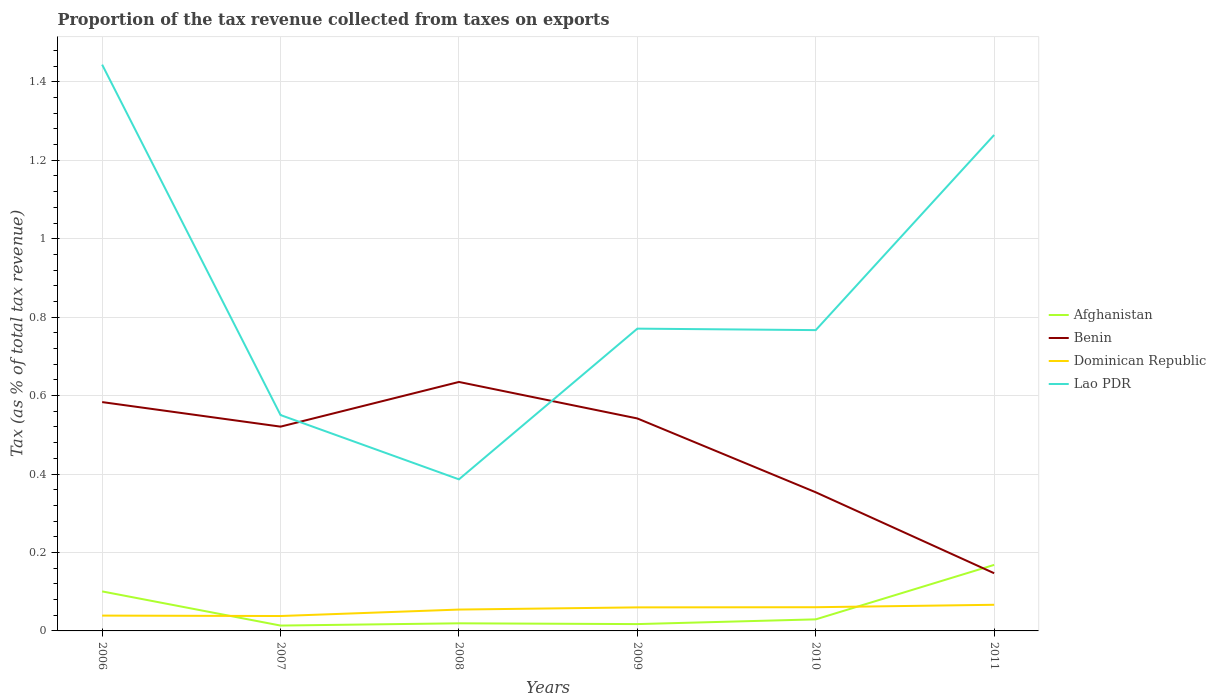How many different coloured lines are there?
Your answer should be compact. 4. Does the line corresponding to Lao PDR intersect with the line corresponding to Afghanistan?
Offer a very short reply. No. Is the number of lines equal to the number of legend labels?
Make the answer very short. Yes. Across all years, what is the maximum proportion of the tax revenue collected in Lao PDR?
Offer a very short reply. 0.39. What is the total proportion of the tax revenue collected in Afghanistan in the graph?
Offer a very short reply. -0.15. What is the difference between the highest and the second highest proportion of the tax revenue collected in Benin?
Keep it short and to the point. 0.49. What is the difference between the highest and the lowest proportion of the tax revenue collected in Lao PDR?
Provide a succinct answer. 2. Is the proportion of the tax revenue collected in Lao PDR strictly greater than the proportion of the tax revenue collected in Dominican Republic over the years?
Ensure brevity in your answer.  No. How many lines are there?
Ensure brevity in your answer.  4. Are the values on the major ticks of Y-axis written in scientific E-notation?
Provide a succinct answer. No. Does the graph contain any zero values?
Keep it short and to the point. No. Where does the legend appear in the graph?
Ensure brevity in your answer.  Center right. What is the title of the graph?
Make the answer very short. Proportion of the tax revenue collected from taxes on exports. Does "Israel" appear as one of the legend labels in the graph?
Your answer should be compact. No. What is the label or title of the Y-axis?
Offer a terse response. Tax (as % of total tax revenue). What is the Tax (as % of total tax revenue) of Afghanistan in 2006?
Make the answer very short. 0.1. What is the Tax (as % of total tax revenue) in Benin in 2006?
Give a very brief answer. 0.58. What is the Tax (as % of total tax revenue) of Dominican Republic in 2006?
Provide a succinct answer. 0.04. What is the Tax (as % of total tax revenue) in Lao PDR in 2006?
Offer a terse response. 1.44. What is the Tax (as % of total tax revenue) of Afghanistan in 2007?
Provide a succinct answer. 0.01. What is the Tax (as % of total tax revenue) of Benin in 2007?
Ensure brevity in your answer.  0.52. What is the Tax (as % of total tax revenue) of Dominican Republic in 2007?
Provide a short and direct response. 0.04. What is the Tax (as % of total tax revenue) of Lao PDR in 2007?
Your answer should be compact. 0.55. What is the Tax (as % of total tax revenue) in Afghanistan in 2008?
Give a very brief answer. 0.02. What is the Tax (as % of total tax revenue) in Benin in 2008?
Offer a very short reply. 0.63. What is the Tax (as % of total tax revenue) of Dominican Republic in 2008?
Keep it short and to the point. 0.05. What is the Tax (as % of total tax revenue) of Lao PDR in 2008?
Provide a short and direct response. 0.39. What is the Tax (as % of total tax revenue) in Afghanistan in 2009?
Make the answer very short. 0.02. What is the Tax (as % of total tax revenue) in Benin in 2009?
Ensure brevity in your answer.  0.54. What is the Tax (as % of total tax revenue) of Dominican Republic in 2009?
Provide a succinct answer. 0.06. What is the Tax (as % of total tax revenue) of Lao PDR in 2009?
Offer a very short reply. 0.77. What is the Tax (as % of total tax revenue) in Afghanistan in 2010?
Make the answer very short. 0.03. What is the Tax (as % of total tax revenue) in Benin in 2010?
Make the answer very short. 0.35. What is the Tax (as % of total tax revenue) of Dominican Republic in 2010?
Your answer should be very brief. 0.06. What is the Tax (as % of total tax revenue) in Lao PDR in 2010?
Provide a short and direct response. 0.77. What is the Tax (as % of total tax revenue) in Afghanistan in 2011?
Offer a very short reply. 0.17. What is the Tax (as % of total tax revenue) of Benin in 2011?
Ensure brevity in your answer.  0.15. What is the Tax (as % of total tax revenue) of Dominican Republic in 2011?
Offer a terse response. 0.07. What is the Tax (as % of total tax revenue) of Lao PDR in 2011?
Your answer should be compact. 1.26. Across all years, what is the maximum Tax (as % of total tax revenue) in Afghanistan?
Ensure brevity in your answer.  0.17. Across all years, what is the maximum Tax (as % of total tax revenue) of Benin?
Offer a very short reply. 0.63. Across all years, what is the maximum Tax (as % of total tax revenue) of Dominican Republic?
Keep it short and to the point. 0.07. Across all years, what is the maximum Tax (as % of total tax revenue) of Lao PDR?
Make the answer very short. 1.44. Across all years, what is the minimum Tax (as % of total tax revenue) of Afghanistan?
Provide a succinct answer. 0.01. Across all years, what is the minimum Tax (as % of total tax revenue) in Benin?
Make the answer very short. 0.15. Across all years, what is the minimum Tax (as % of total tax revenue) in Dominican Republic?
Offer a very short reply. 0.04. Across all years, what is the minimum Tax (as % of total tax revenue) in Lao PDR?
Provide a short and direct response. 0.39. What is the total Tax (as % of total tax revenue) in Afghanistan in the graph?
Offer a terse response. 0.35. What is the total Tax (as % of total tax revenue) of Benin in the graph?
Your answer should be compact. 2.78. What is the total Tax (as % of total tax revenue) in Dominican Republic in the graph?
Make the answer very short. 0.32. What is the total Tax (as % of total tax revenue) in Lao PDR in the graph?
Give a very brief answer. 5.18. What is the difference between the Tax (as % of total tax revenue) of Afghanistan in 2006 and that in 2007?
Your response must be concise. 0.09. What is the difference between the Tax (as % of total tax revenue) of Benin in 2006 and that in 2007?
Make the answer very short. 0.06. What is the difference between the Tax (as % of total tax revenue) of Dominican Republic in 2006 and that in 2007?
Give a very brief answer. 0. What is the difference between the Tax (as % of total tax revenue) in Lao PDR in 2006 and that in 2007?
Ensure brevity in your answer.  0.89. What is the difference between the Tax (as % of total tax revenue) of Afghanistan in 2006 and that in 2008?
Make the answer very short. 0.08. What is the difference between the Tax (as % of total tax revenue) of Benin in 2006 and that in 2008?
Offer a terse response. -0.05. What is the difference between the Tax (as % of total tax revenue) of Dominican Republic in 2006 and that in 2008?
Provide a succinct answer. -0.02. What is the difference between the Tax (as % of total tax revenue) in Lao PDR in 2006 and that in 2008?
Your answer should be very brief. 1.06. What is the difference between the Tax (as % of total tax revenue) of Afghanistan in 2006 and that in 2009?
Provide a succinct answer. 0.08. What is the difference between the Tax (as % of total tax revenue) in Benin in 2006 and that in 2009?
Your response must be concise. 0.04. What is the difference between the Tax (as % of total tax revenue) in Dominican Republic in 2006 and that in 2009?
Make the answer very short. -0.02. What is the difference between the Tax (as % of total tax revenue) of Lao PDR in 2006 and that in 2009?
Offer a terse response. 0.67. What is the difference between the Tax (as % of total tax revenue) of Afghanistan in 2006 and that in 2010?
Provide a short and direct response. 0.07. What is the difference between the Tax (as % of total tax revenue) in Benin in 2006 and that in 2010?
Your answer should be compact. 0.23. What is the difference between the Tax (as % of total tax revenue) of Dominican Republic in 2006 and that in 2010?
Keep it short and to the point. -0.02. What is the difference between the Tax (as % of total tax revenue) of Lao PDR in 2006 and that in 2010?
Your answer should be compact. 0.68. What is the difference between the Tax (as % of total tax revenue) in Afghanistan in 2006 and that in 2011?
Keep it short and to the point. -0.07. What is the difference between the Tax (as % of total tax revenue) in Benin in 2006 and that in 2011?
Offer a terse response. 0.44. What is the difference between the Tax (as % of total tax revenue) of Dominican Republic in 2006 and that in 2011?
Provide a short and direct response. -0.03. What is the difference between the Tax (as % of total tax revenue) of Lao PDR in 2006 and that in 2011?
Your answer should be compact. 0.18. What is the difference between the Tax (as % of total tax revenue) of Afghanistan in 2007 and that in 2008?
Provide a succinct answer. -0.01. What is the difference between the Tax (as % of total tax revenue) of Benin in 2007 and that in 2008?
Give a very brief answer. -0.11. What is the difference between the Tax (as % of total tax revenue) in Dominican Republic in 2007 and that in 2008?
Offer a very short reply. -0.02. What is the difference between the Tax (as % of total tax revenue) of Lao PDR in 2007 and that in 2008?
Your answer should be very brief. 0.16. What is the difference between the Tax (as % of total tax revenue) of Afghanistan in 2007 and that in 2009?
Offer a terse response. -0. What is the difference between the Tax (as % of total tax revenue) in Benin in 2007 and that in 2009?
Provide a succinct answer. -0.02. What is the difference between the Tax (as % of total tax revenue) of Dominican Republic in 2007 and that in 2009?
Provide a succinct answer. -0.02. What is the difference between the Tax (as % of total tax revenue) in Lao PDR in 2007 and that in 2009?
Your answer should be compact. -0.22. What is the difference between the Tax (as % of total tax revenue) of Afghanistan in 2007 and that in 2010?
Your answer should be compact. -0.02. What is the difference between the Tax (as % of total tax revenue) of Benin in 2007 and that in 2010?
Offer a very short reply. 0.17. What is the difference between the Tax (as % of total tax revenue) of Dominican Republic in 2007 and that in 2010?
Ensure brevity in your answer.  -0.02. What is the difference between the Tax (as % of total tax revenue) in Lao PDR in 2007 and that in 2010?
Offer a very short reply. -0.22. What is the difference between the Tax (as % of total tax revenue) of Afghanistan in 2007 and that in 2011?
Offer a terse response. -0.15. What is the difference between the Tax (as % of total tax revenue) in Benin in 2007 and that in 2011?
Offer a terse response. 0.37. What is the difference between the Tax (as % of total tax revenue) of Dominican Republic in 2007 and that in 2011?
Provide a short and direct response. -0.03. What is the difference between the Tax (as % of total tax revenue) of Lao PDR in 2007 and that in 2011?
Offer a very short reply. -0.71. What is the difference between the Tax (as % of total tax revenue) of Afghanistan in 2008 and that in 2009?
Keep it short and to the point. 0. What is the difference between the Tax (as % of total tax revenue) of Benin in 2008 and that in 2009?
Your response must be concise. 0.09. What is the difference between the Tax (as % of total tax revenue) of Dominican Republic in 2008 and that in 2009?
Keep it short and to the point. -0.01. What is the difference between the Tax (as % of total tax revenue) of Lao PDR in 2008 and that in 2009?
Keep it short and to the point. -0.38. What is the difference between the Tax (as % of total tax revenue) in Afghanistan in 2008 and that in 2010?
Ensure brevity in your answer.  -0.01. What is the difference between the Tax (as % of total tax revenue) in Benin in 2008 and that in 2010?
Provide a succinct answer. 0.28. What is the difference between the Tax (as % of total tax revenue) of Dominican Republic in 2008 and that in 2010?
Give a very brief answer. -0.01. What is the difference between the Tax (as % of total tax revenue) of Lao PDR in 2008 and that in 2010?
Provide a short and direct response. -0.38. What is the difference between the Tax (as % of total tax revenue) in Afghanistan in 2008 and that in 2011?
Keep it short and to the point. -0.15. What is the difference between the Tax (as % of total tax revenue) in Benin in 2008 and that in 2011?
Provide a short and direct response. 0.49. What is the difference between the Tax (as % of total tax revenue) of Dominican Republic in 2008 and that in 2011?
Provide a succinct answer. -0.01. What is the difference between the Tax (as % of total tax revenue) of Lao PDR in 2008 and that in 2011?
Ensure brevity in your answer.  -0.88. What is the difference between the Tax (as % of total tax revenue) in Afghanistan in 2009 and that in 2010?
Your answer should be very brief. -0.01. What is the difference between the Tax (as % of total tax revenue) in Benin in 2009 and that in 2010?
Provide a succinct answer. 0.19. What is the difference between the Tax (as % of total tax revenue) in Dominican Republic in 2009 and that in 2010?
Your response must be concise. -0. What is the difference between the Tax (as % of total tax revenue) of Lao PDR in 2009 and that in 2010?
Your answer should be very brief. 0. What is the difference between the Tax (as % of total tax revenue) in Afghanistan in 2009 and that in 2011?
Provide a succinct answer. -0.15. What is the difference between the Tax (as % of total tax revenue) in Benin in 2009 and that in 2011?
Make the answer very short. 0.39. What is the difference between the Tax (as % of total tax revenue) of Dominican Republic in 2009 and that in 2011?
Give a very brief answer. -0.01. What is the difference between the Tax (as % of total tax revenue) of Lao PDR in 2009 and that in 2011?
Ensure brevity in your answer.  -0.49. What is the difference between the Tax (as % of total tax revenue) of Afghanistan in 2010 and that in 2011?
Provide a short and direct response. -0.14. What is the difference between the Tax (as % of total tax revenue) of Benin in 2010 and that in 2011?
Make the answer very short. 0.21. What is the difference between the Tax (as % of total tax revenue) in Dominican Republic in 2010 and that in 2011?
Give a very brief answer. -0.01. What is the difference between the Tax (as % of total tax revenue) of Lao PDR in 2010 and that in 2011?
Make the answer very short. -0.5. What is the difference between the Tax (as % of total tax revenue) in Afghanistan in 2006 and the Tax (as % of total tax revenue) in Benin in 2007?
Ensure brevity in your answer.  -0.42. What is the difference between the Tax (as % of total tax revenue) in Afghanistan in 2006 and the Tax (as % of total tax revenue) in Dominican Republic in 2007?
Give a very brief answer. 0.06. What is the difference between the Tax (as % of total tax revenue) of Afghanistan in 2006 and the Tax (as % of total tax revenue) of Lao PDR in 2007?
Your answer should be compact. -0.45. What is the difference between the Tax (as % of total tax revenue) of Benin in 2006 and the Tax (as % of total tax revenue) of Dominican Republic in 2007?
Offer a very short reply. 0.55. What is the difference between the Tax (as % of total tax revenue) of Benin in 2006 and the Tax (as % of total tax revenue) of Lao PDR in 2007?
Your answer should be very brief. 0.03. What is the difference between the Tax (as % of total tax revenue) in Dominican Republic in 2006 and the Tax (as % of total tax revenue) in Lao PDR in 2007?
Your answer should be compact. -0.51. What is the difference between the Tax (as % of total tax revenue) of Afghanistan in 2006 and the Tax (as % of total tax revenue) of Benin in 2008?
Offer a terse response. -0.53. What is the difference between the Tax (as % of total tax revenue) in Afghanistan in 2006 and the Tax (as % of total tax revenue) in Dominican Republic in 2008?
Keep it short and to the point. 0.05. What is the difference between the Tax (as % of total tax revenue) in Afghanistan in 2006 and the Tax (as % of total tax revenue) in Lao PDR in 2008?
Make the answer very short. -0.29. What is the difference between the Tax (as % of total tax revenue) in Benin in 2006 and the Tax (as % of total tax revenue) in Dominican Republic in 2008?
Your response must be concise. 0.53. What is the difference between the Tax (as % of total tax revenue) of Benin in 2006 and the Tax (as % of total tax revenue) of Lao PDR in 2008?
Offer a terse response. 0.2. What is the difference between the Tax (as % of total tax revenue) of Dominican Republic in 2006 and the Tax (as % of total tax revenue) of Lao PDR in 2008?
Make the answer very short. -0.35. What is the difference between the Tax (as % of total tax revenue) in Afghanistan in 2006 and the Tax (as % of total tax revenue) in Benin in 2009?
Offer a very short reply. -0.44. What is the difference between the Tax (as % of total tax revenue) in Afghanistan in 2006 and the Tax (as % of total tax revenue) in Dominican Republic in 2009?
Ensure brevity in your answer.  0.04. What is the difference between the Tax (as % of total tax revenue) of Afghanistan in 2006 and the Tax (as % of total tax revenue) of Lao PDR in 2009?
Your answer should be very brief. -0.67. What is the difference between the Tax (as % of total tax revenue) of Benin in 2006 and the Tax (as % of total tax revenue) of Dominican Republic in 2009?
Ensure brevity in your answer.  0.52. What is the difference between the Tax (as % of total tax revenue) in Benin in 2006 and the Tax (as % of total tax revenue) in Lao PDR in 2009?
Provide a succinct answer. -0.19. What is the difference between the Tax (as % of total tax revenue) of Dominican Republic in 2006 and the Tax (as % of total tax revenue) of Lao PDR in 2009?
Offer a very short reply. -0.73. What is the difference between the Tax (as % of total tax revenue) in Afghanistan in 2006 and the Tax (as % of total tax revenue) in Benin in 2010?
Your answer should be very brief. -0.25. What is the difference between the Tax (as % of total tax revenue) of Afghanistan in 2006 and the Tax (as % of total tax revenue) of Dominican Republic in 2010?
Your response must be concise. 0.04. What is the difference between the Tax (as % of total tax revenue) in Afghanistan in 2006 and the Tax (as % of total tax revenue) in Lao PDR in 2010?
Your response must be concise. -0.67. What is the difference between the Tax (as % of total tax revenue) in Benin in 2006 and the Tax (as % of total tax revenue) in Dominican Republic in 2010?
Make the answer very short. 0.52. What is the difference between the Tax (as % of total tax revenue) of Benin in 2006 and the Tax (as % of total tax revenue) of Lao PDR in 2010?
Your response must be concise. -0.18. What is the difference between the Tax (as % of total tax revenue) of Dominican Republic in 2006 and the Tax (as % of total tax revenue) of Lao PDR in 2010?
Your answer should be compact. -0.73. What is the difference between the Tax (as % of total tax revenue) in Afghanistan in 2006 and the Tax (as % of total tax revenue) in Benin in 2011?
Provide a succinct answer. -0.05. What is the difference between the Tax (as % of total tax revenue) of Afghanistan in 2006 and the Tax (as % of total tax revenue) of Dominican Republic in 2011?
Provide a short and direct response. 0.03. What is the difference between the Tax (as % of total tax revenue) in Afghanistan in 2006 and the Tax (as % of total tax revenue) in Lao PDR in 2011?
Ensure brevity in your answer.  -1.16. What is the difference between the Tax (as % of total tax revenue) in Benin in 2006 and the Tax (as % of total tax revenue) in Dominican Republic in 2011?
Your answer should be very brief. 0.52. What is the difference between the Tax (as % of total tax revenue) of Benin in 2006 and the Tax (as % of total tax revenue) of Lao PDR in 2011?
Provide a short and direct response. -0.68. What is the difference between the Tax (as % of total tax revenue) of Dominican Republic in 2006 and the Tax (as % of total tax revenue) of Lao PDR in 2011?
Make the answer very short. -1.23. What is the difference between the Tax (as % of total tax revenue) in Afghanistan in 2007 and the Tax (as % of total tax revenue) in Benin in 2008?
Offer a terse response. -0.62. What is the difference between the Tax (as % of total tax revenue) of Afghanistan in 2007 and the Tax (as % of total tax revenue) of Dominican Republic in 2008?
Offer a terse response. -0.04. What is the difference between the Tax (as % of total tax revenue) of Afghanistan in 2007 and the Tax (as % of total tax revenue) of Lao PDR in 2008?
Ensure brevity in your answer.  -0.37. What is the difference between the Tax (as % of total tax revenue) in Benin in 2007 and the Tax (as % of total tax revenue) in Dominican Republic in 2008?
Your answer should be very brief. 0.47. What is the difference between the Tax (as % of total tax revenue) in Benin in 2007 and the Tax (as % of total tax revenue) in Lao PDR in 2008?
Provide a short and direct response. 0.13. What is the difference between the Tax (as % of total tax revenue) of Dominican Republic in 2007 and the Tax (as % of total tax revenue) of Lao PDR in 2008?
Keep it short and to the point. -0.35. What is the difference between the Tax (as % of total tax revenue) in Afghanistan in 2007 and the Tax (as % of total tax revenue) in Benin in 2009?
Provide a short and direct response. -0.53. What is the difference between the Tax (as % of total tax revenue) of Afghanistan in 2007 and the Tax (as % of total tax revenue) of Dominican Republic in 2009?
Make the answer very short. -0.05. What is the difference between the Tax (as % of total tax revenue) of Afghanistan in 2007 and the Tax (as % of total tax revenue) of Lao PDR in 2009?
Ensure brevity in your answer.  -0.76. What is the difference between the Tax (as % of total tax revenue) of Benin in 2007 and the Tax (as % of total tax revenue) of Dominican Republic in 2009?
Provide a short and direct response. 0.46. What is the difference between the Tax (as % of total tax revenue) in Benin in 2007 and the Tax (as % of total tax revenue) in Lao PDR in 2009?
Your answer should be compact. -0.25. What is the difference between the Tax (as % of total tax revenue) of Dominican Republic in 2007 and the Tax (as % of total tax revenue) of Lao PDR in 2009?
Your answer should be very brief. -0.73. What is the difference between the Tax (as % of total tax revenue) of Afghanistan in 2007 and the Tax (as % of total tax revenue) of Benin in 2010?
Keep it short and to the point. -0.34. What is the difference between the Tax (as % of total tax revenue) of Afghanistan in 2007 and the Tax (as % of total tax revenue) of Dominican Republic in 2010?
Ensure brevity in your answer.  -0.05. What is the difference between the Tax (as % of total tax revenue) in Afghanistan in 2007 and the Tax (as % of total tax revenue) in Lao PDR in 2010?
Give a very brief answer. -0.75. What is the difference between the Tax (as % of total tax revenue) of Benin in 2007 and the Tax (as % of total tax revenue) of Dominican Republic in 2010?
Ensure brevity in your answer.  0.46. What is the difference between the Tax (as % of total tax revenue) of Benin in 2007 and the Tax (as % of total tax revenue) of Lao PDR in 2010?
Keep it short and to the point. -0.25. What is the difference between the Tax (as % of total tax revenue) of Dominican Republic in 2007 and the Tax (as % of total tax revenue) of Lao PDR in 2010?
Provide a succinct answer. -0.73. What is the difference between the Tax (as % of total tax revenue) in Afghanistan in 2007 and the Tax (as % of total tax revenue) in Benin in 2011?
Make the answer very short. -0.13. What is the difference between the Tax (as % of total tax revenue) of Afghanistan in 2007 and the Tax (as % of total tax revenue) of Dominican Republic in 2011?
Your response must be concise. -0.05. What is the difference between the Tax (as % of total tax revenue) of Afghanistan in 2007 and the Tax (as % of total tax revenue) of Lao PDR in 2011?
Offer a terse response. -1.25. What is the difference between the Tax (as % of total tax revenue) of Benin in 2007 and the Tax (as % of total tax revenue) of Dominican Republic in 2011?
Provide a short and direct response. 0.45. What is the difference between the Tax (as % of total tax revenue) in Benin in 2007 and the Tax (as % of total tax revenue) in Lao PDR in 2011?
Your response must be concise. -0.74. What is the difference between the Tax (as % of total tax revenue) in Dominican Republic in 2007 and the Tax (as % of total tax revenue) in Lao PDR in 2011?
Ensure brevity in your answer.  -1.23. What is the difference between the Tax (as % of total tax revenue) of Afghanistan in 2008 and the Tax (as % of total tax revenue) of Benin in 2009?
Your response must be concise. -0.52. What is the difference between the Tax (as % of total tax revenue) of Afghanistan in 2008 and the Tax (as % of total tax revenue) of Dominican Republic in 2009?
Your response must be concise. -0.04. What is the difference between the Tax (as % of total tax revenue) in Afghanistan in 2008 and the Tax (as % of total tax revenue) in Lao PDR in 2009?
Make the answer very short. -0.75. What is the difference between the Tax (as % of total tax revenue) of Benin in 2008 and the Tax (as % of total tax revenue) of Dominican Republic in 2009?
Keep it short and to the point. 0.57. What is the difference between the Tax (as % of total tax revenue) in Benin in 2008 and the Tax (as % of total tax revenue) in Lao PDR in 2009?
Make the answer very short. -0.14. What is the difference between the Tax (as % of total tax revenue) of Dominican Republic in 2008 and the Tax (as % of total tax revenue) of Lao PDR in 2009?
Offer a very short reply. -0.72. What is the difference between the Tax (as % of total tax revenue) in Afghanistan in 2008 and the Tax (as % of total tax revenue) in Benin in 2010?
Offer a terse response. -0.33. What is the difference between the Tax (as % of total tax revenue) of Afghanistan in 2008 and the Tax (as % of total tax revenue) of Dominican Republic in 2010?
Keep it short and to the point. -0.04. What is the difference between the Tax (as % of total tax revenue) of Afghanistan in 2008 and the Tax (as % of total tax revenue) of Lao PDR in 2010?
Offer a terse response. -0.75. What is the difference between the Tax (as % of total tax revenue) in Benin in 2008 and the Tax (as % of total tax revenue) in Dominican Republic in 2010?
Offer a very short reply. 0.57. What is the difference between the Tax (as % of total tax revenue) of Benin in 2008 and the Tax (as % of total tax revenue) of Lao PDR in 2010?
Your response must be concise. -0.13. What is the difference between the Tax (as % of total tax revenue) in Dominican Republic in 2008 and the Tax (as % of total tax revenue) in Lao PDR in 2010?
Make the answer very short. -0.71. What is the difference between the Tax (as % of total tax revenue) in Afghanistan in 2008 and the Tax (as % of total tax revenue) in Benin in 2011?
Your response must be concise. -0.13. What is the difference between the Tax (as % of total tax revenue) of Afghanistan in 2008 and the Tax (as % of total tax revenue) of Dominican Republic in 2011?
Make the answer very short. -0.05. What is the difference between the Tax (as % of total tax revenue) in Afghanistan in 2008 and the Tax (as % of total tax revenue) in Lao PDR in 2011?
Provide a short and direct response. -1.25. What is the difference between the Tax (as % of total tax revenue) in Benin in 2008 and the Tax (as % of total tax revenue) in Dominican Republic in 2011?
Your answer should be compact. 0.57. What is the difference between the Tax (as % of total tax revenue) of Benin in 2008 and the Tax (as % of total tax revenue) of Lao PDR in 2011?
Ensure brevity in your answer.  -0.63. What is the difference between the Tax (as % of total tax revenue) in Dominican Republic in 2008 and the Tax (as % of total tax revenue) in Lao PDR in 2011?
Provide a succinct answer. -1.21. What is the difference between the Tax (as % of total tax revenue) of Afghanistan in 2009 and the Tax (as % of total tax revenue) of Benin in 2010?
Keep it short and to the point. -0.34. What is the difference between the Tax (as % of total tax revenue) in Afghanistan in 2009 and the Tax (as % of total tax revenue) in Dominican Republic in 2010?
Offer a terse response. -0.04. What is the difference between the Tax (as % of total tax revenue) in Afghanistan in 2009 and the Tax (as % of total tax revenue) in Lao PDR in 2010?
Offer a terse response. -0.75. What is the difference between the Tax (as % of total tax revenue) of Benin in 2009 and the Tax (as % of total tax revenue) of Dominican Republic in 2010?
Offer a terse response. 0.48. What is the difference between the Tax (as % of total tax revenue) of Benin in 2009 and the Tax (as % of total tax revenue) of Lao PDR in 2010?
Provide a short and direct response. -0.23. What is the difference between the Tax (as % of total tax revenue) of Dominican Republic in 2009 and the Tax (as % of total tax revenue) of Lao PDR in 2010?
Your answer should be very brief. -0.71. What is the difference between the Tax (as % of total tax revenue) in Afghanistan in 2009 and the Tax (as % of total tax revenue) in Benin in 2011?
Give a very brief answer. -0.13. What is the difference between the Tax (as % of total tax revenue) of Afghanistan in 2009 and the Tax (as % of total tax revenue) of Dominican Republic in 2011?
Your answer should be very brief. -0.05. What is the difference between the Tax (as % of total tax revenue) in Afghanistan in 2009 and the Tax (as % of total tax revenue) in Lao PDR in 2011?
Give a very brief answer. -1.25. What is the difference between the Tax (as % of total tax revenue) in Benin in 2009 and the Tax (as % of total tax revenue) in Dominican Republic in 2011?
Ensure brevity in your answer.  0.47. What is the difference between the Tax (as % of total tax revenue) in Benin in 2009 and the Tax (as % of total tax revenue) in Lao PDR in 2011?
Keep it short and to the point. -0.72. What is the difference between the Tax (as % of total tax revenue) of Dominican Republic in 2009 and the Tax (as % of total tax revenue) of Lao PDR in 2011?
Provide a short and direct response. -1.2. What is the difference between the Tax (as % of total tax revenue) of Afghanistan in 2010 and the Tax (as % of total tax revenue) of Benin in 2011?
Ensure brevity in your answer.  -0.12. What is the difference between the Tax (as % of total tax revenue) in Afghanistan in 2010 and the Tax (as % of total tax revenue) in Dominican Republic in 2011?
Your response must be concise. -0.04. What is the difference between the Tax (as % of total tax revenue) of Afghanistan in 2010 and the Tax (as % of total tax revenue) of Lao PDR in 2011?
Your answer should be compact. -1.24. What is the difference between the Tax (as % of total tax revenue) of Benin in 2010 and the Tax (as % of total tax revenue) of Dominican Republic in 2011?
Offer a very short reply. 0.29. What is the difference between the Tax (as % of total tax revenue) of Benin in 2010 and the Tax (as % of total tax revenue) of Lao PDR in 2011?
Your answer should be very brief. -0.91. What is the difference between the Tax (as % of total tax revenue) of Dominican Republic in 2010 and the Tax (as % of total tax revenue) of Lao PDR in 2011?
Keep it short and to the point. -1.2. What is the average Tax (as % of total tax revenue) in Afghanistan per year?
Your response must be concise. 0.06. What is the average Tax (as % of total tax revenue) of Benin per year?
Keep it short and to the point. 0.46. What is the average Tax (as % of total tax revenue) of Dominican Republic per year?
Ensure brevity in your answer.  0.05. What is the average Tax (as % of total tax revenue) in Lao PDR per year?
Offer a terse response. 0.86. In the year 2006, what is the difference between the Tax (as % of total tax revenue) in Afghanistan and Tax (as % of total tax revenue) in Benin?
Your answer should be very brief. -0.48. In the year 2006, what is the difference between the Tax (as % of total tax revenue) in Afghanistan and Tax (as % of total tax revenue) in Dominican Republic?
Provide a succinct answer. 0.06. In the year 2006, what is the difference between the Tax (as % of total tax revenue) in Afghanistan and Tax (as % of total tax revenue) in Lao PDR?
Ensure brevity in your answer.  -1.34. In the year 2006, what is the difference between the Tax (as % of total tax revenue) in Benin and Tax (as % of total tax revenue) in Dominican Republic?
Keep it short and to the point. 0.54. In the year 2006, what is the difference between the Tax (as % of total tax revenue) in Benin and Tax (as % of total tax revenue) in Lao PDR?
Keep it short and to the point. -0.86. In the year 2006, what is the difference between the Tax (as % of total tax revenue) of Dominican Republic and Tax (as % of total tax revenue) of Lao PDR?
Give a very brief answer. -1.4. In the year 2007, what is the difference between the Tax (as % of total tax revenue) in Afghanistan and Tax (as % of total tax revenue) in Benin?
Your answer should be very brief. -0.51. In the year 2007, what is the difference between the Tax (as % of total tax revenue) of Afghanistan and Tax (as % of total tax revenue) of Dominican Republic?
Keep it short and to the point. -0.02. In the year 2007, what is the difference between the Tax (as % of total tax revenue) of Afghanistan and Tax (as % of total tax revenue) of Lao PDR?
Your answer should be very brief. -0.54. In the year 2007, what is the difference between the Tax (as % of total tax revenue) in Benin and Tax (as % of total tax revenue) in Dominican Republic?
Your response must be concise. 0.48. In the year 2007, what is the difference between the Tax (as % of total tax revenue) in Benin and Tax (as % of total tax revenue) in Lao PDR?
Keep it short and to the point. -0.03. In the year 2007, what is the difference between the Tax (as % of total tax revenue) of Dominican Republic and Tax (as % of total tax revenue) of Lao PDR?
Provide a succinct answer. -0.51. In the year 2008, what is the difference between the Tax (as % of total tax revenue) in Afghanistan and Tax (as % of total tax revenue) in Benin?
Your response must be concise. -0.62. In the year 2008, what is the difference between the Tax (as % of total tax revenue) in Afghanistan and Tax (as % of total tax revenue) in Dominican Republic?
Keep it short and to the point. -0.04. In the year 2008, what is the difference between the Tax (as % of total tax revenue) in Afghanistan and Tax (as % of total tax revenue) in Lao PDR?
Provide a succinct answer. -0.37. In the year 2008, what is the difference between the Tax (as % of total tax revenue) of Benin and Tax (as % of total tax revenue) of Dominican Republic?
Offer a terse response. 0.58. In the year 2008, what is the difference between the Tax (as % of total tax revenue) of Benin and Tax (as % of total tax revenue) of Lao PDR?
Your answer should be compact. 0.25. In the year 2008, what is the difference between the Tax (as % of total tax revenue) in Dominican Republic and Tax (as % of total tax revenue) in Lao PDR?
Your answer should be very brief. -0.33. In the year 2009, what is the difference between the Tax (as % of total tax revenue) of Afghanistan and Tax (as % of total tax revenue) of Benin?
Your answer should be very brief. -0.52. In the year 2009, what is the difference between the Tax (as % of total tax revenue) in Afghanistan and Tax (as % of total tax revenue) in Dominican Republic?
Your answer should be very brief. -0.04. In the year 2009, what is the difference between the Tax (as % of total tax revenue) of Afghanistan and Tax (as % of total tax revenue) of Lao PDR?
Your response must be concise. -0.75. In the year 2009, what is the difference between the Tax (as % of total tax revenue) of Benin and Tax (as % of total tax revenue) of Dominican Republic?
Make the answer very short. 0.48. In the year 2009, what is the difference between the Tax (as % of total tax revenue) of Benin and Tax (as % of total tax revenue) of Lao PDR?
Keep it short and to the point. -0.23. In the year 2009, what is the difference between the Tax (as % of total tax revenue) in Dominican Republic and Tax (as % of total tax revenue) in Lao PDR?
Provide a short and direct response. -0.71. In the year 2010, what is the difference between the Tax (as % of total tax revenue) of Afghanistan and Tax (as % of total tax revenue) of Benin?
Your response must be concise. -0.32. In the year 2010, what is the difference between the Tax (as % of total tax revenue) of Afghanistan and Tax (as % of total tax revenue) of Dominican Republic?
Ensure brevity in your answer.  -0.03. In the year 2010, what is the difference between the Tax (as % of total tax revenue) of Afghanistan and Tax (as % of total tax revenue) of Lao PDR?
Your response must be concise. -0.74. In the year 2010, what is the difference between the Tax (as % of total tax revenue) of Benin and Tax (as % of total tax revenue) of Dominican Republic?
Provide a succinct answer. 0.29. In the year 2010, what is the difference between the Tax (as % of total tax revenue) in Benin and Tax (as % of total tax revenue) in Lao PDR?
Ensure brevity in your answer.  -0.41. In the year 2010, what is the difference between the Tax (as % of total tax revenue) in Dominican Republic and Tax (as % of total tax revenue) in Lao PDR?
Make the answer very short. -0.71. In the year 2011, what is the difference between the Tax (as % of total tax revenue) in Afghanistan and Tax (as % of total tax revenue) in Benin?
Your answer should be compact. 0.02. In the year 2011, what is the difference between the Tax (as % of total tax revenue) in Afghanistan and Tax (as % of total tax revenue) in Dominican Republic?
Your response must be concise. 0.1. In the year 2011, what is the difference between the Tax (as % of total tax revenue) in Afghanistan and Tax (as % of total tax revenue) in Lao PDR?
Offer a terse response. -1.1. In the year 2011, what is the difference between the Tax (as % of total tax revenue) of Benin and Tax (as % of total tax revenue) of Dominican Republic?
Provide a succinct answer. 0.08. In the year 2011, what is the difference between the Tax (as % of total tax revenue) in Benin and Tax (as % of total tax revenue) in Lao PDR?
Keep it short and to the point. -1.12. In the year 2011, what is the difference between the Tax (as % of total tax revenue) of Dominican Republic and Tax (as % of total tax revenue) of Lao PDR?
Your response must be concise. -1.2. What is the ratio of the Tax (as % of total tax revenue) in Afghanistan in 2006 to that in 2007?
Make the answer very short. 7.37. What is the ratio of the Tax (as % of total tax revenue) of Benin in 2006 to that in 2007?
Your answer should be compact. 1.12. What is the ratio of the Tax (as % of total tax revenue) of Dominican Republic in 2006 to that in 2007?
Keep it short and to the point. 1.03. What is the ratio of the Tax (as % of total tax revenue) of Lao PDR in 2006 to that in 2007?
Provide a short and direct response. 2.62. What is the ratio of the Tax (as % of total tax revenue) of Afghanistan in 2006 to that in 2008?
Your answer should be very brief. 5.19. What is the ratio of the Tax (as % of total tax revenue) in Benin in 2006 to that in 2008?
Provide a succinct answer. 0.92. What is the ratio of the Tax (as % of total tax revenue) in Dominican Republic in 2006 to that in 2008?
Keep it short and to the point. 0.72. What is the ratio of the Tax (as % of total tax revenue) in Lao PDR in 2006 to that in 2008?
Make the answer very short. 3.74. What is the ratio of the Tax (as % of total tax revenue) of Afghanistan in 2006 to that in 2009?
Provide a succinct answer. 5.79. What is the ratio of the Tax (as % of total tax revenue) of Benin in 2006 to that in 2009?
Your response must be concise. 1.08. What is the ratio of the Tax (as % of total tax revenue) in Dominican Republic in 2006 to that in 2009?
Your answer should be compact. 0.65. What is the ratio of the Tax (as % of total tax revenue) in Lao PDR in 2006 to that in 2009?
Offer a very short reply. 1.87. What is the ratio of the Tax (as % of total tax revenue) of Afghanistan in 2006 to that in 2010?
Offer a terse response. 3.42. What is the ratio of the Tax (as % of total tax revenue) in Benin in 2006 to that in 2010?
Provide a short and direct response. 1.65. What is the ratio of the Tax (as % of total tax revenue) in Dominican Republic in 2006 to that in 2010?
Your answer should be compact. 0.65. What is the ratio of the Tax (as % of total tax revenue) of Lao PDR in 2006 to that in 2010?
Your answer should be compact. 1.88. What is the ratio of the Tax (as % of total tax revenue) in Afghanistan in 2006 to that in 2011?
Offer a very short reply. 0.6. What is the ratio of the Tax (as % of total tax revenue) of Benin in 2006 to that in 2011?
Ensure brevity in your answer.  3.97. What is the ratio of the Tax (as % of total tax revenue) in Dominican Republic in 2006 to that in 2011?
Offer a terse response. 0.59. What is the ratio of the Tax (as % of total tax revenue) in Lao PDR in 2006 to that in 2011?
Keep it short and to the point. 1.14. What is the ratio of the Tax (as % of total tax revenue) of Afghanistan in 2007 to that in 2008?
Offer a terse response. 0.7. What is the ratio of the Tax (as % of total tax revenue) of Benin in 2007 to that in 2008?
Offer a terse response. 0.82. What is the ratio of the Tax (as % of total tax revenue) of Dominican Republic in 2007 to that in 2008?
Ensure brevity in your answer.  0.7. What is the ratio of the Tax (as % of total tax revenue) of Lao PDR in 2007 to that in 2008?
Your answer should be very brief. 1.42. What is the ratio of the Tax (as % of total tax revenue) in Afghanistan in 2007 to that in 2009?
Make the answer very short. 0.79. What is the ratio of the Tax (as % of total tax revenue) of Benin in 2007 to that in 2009?
Provide a short and direct response. 0.96. What is the ratio of the Tax (as % of total tax revenue) of Dominican Republic in 2007 to that in 2009?
Provide a short and direct response. 0.63. What is the ratio of the Tax (as % of total tax revenue) of Lao PDR in 2007 to that in 2009?
Give a very brief answer. 0.71. What is the ratio of the Tax (as % of total tax revenue) of Afghanistan in 2007 to that in 2010?
Provide a short and direct response. 0.46. What is the ratio of the Tax (as % of total tax revenue) in Benin in 2007 to that in 2010?
Offer a terse response. 1.47. What is the ratio of the Tax (as % of total tax revenue) in Dominican Republic in 2007 to that in 2010?
Make the answer very short. 0.63. What is the ratio of the Tax (as % of total tax revenue) of Lao PDR in 2007 to that in 2010?
Provide a short and direct response. 0.72. What is the ratio of the Tax (as % of total tax revenue) of Afghanistan in 2007 to that in 2011?
Provide a succinct answer. 0.08. What is the ratio of the Tax (as % of total tax revenue) of Benin in 2007 to that in 2011?
Your response must be concise. 3.54. What is the ratio of the Tax (as % of total tax revenue) of Dominican Republic in 2007 to that in 2011?
Your answer should be very brief. 0.57. What is the ratio of the Tax (as % of total tax revenue) of Lao PDR in 2007 to that in 2011?
Your answer should be compact. 0.44. What is the ratio of the Tax (as % of total tax revenue) in Afghanistan in 2008 to that in 2009?
Your answer should be very brief. 1.12. What is the ratio of the Tax (as % of total tax revenue) of Benin in 2008 to that in 2009?
Keep it short and to the point. 1.17. What is the ratio of the Tax (as % of total tax revenue) of Dominican Republic in 2008 to that in 2009?
Your answer should be very brief. 0.91. What is the ratio of the Tax (as % of total tax revenue) in Lao PDR in 2008 to that in 2009?
Provide a short and direct response. 0.5. What is the ratio of the Tax (as % of total tax revenue) of Afghanistan in 2008 to that in 2010?
Ensure brevity in your answer.  0.66. What is the ratio of the Tax (as % of total tax revenue) of Benin in 2008 to that in 2010?
Offer a very short reply. 1.8. What is the ratio of the Tax (as % of total tax revenue) of Dominican Republic in 2008 to that in 2010?
Your answer should be compact. 0.9. What is the ratio of the Tax (as % of total tax revenue) of Lao PDR in 2008 to that in 2010?
Your response must be concise. 0.5. What is the ratio of the Tax (as % of total tax revenue) in Afghanistan in 2008 to that in 2011?
Offer a very short reply. 0.12. What is the ratio of the Tax (as % of total tax revenue) in Benin in 2008 to that in 2011?
Ensure brevity in your answer.  4.32. What is the ratio of the Tax (as % of total tax revenue) of Dominican Republic in 2008 to that in 2011?
Offer a terse response. 0.82. What is the ratio of the Tax (as % of total tax revenue) in Lao PDR in 2008 to that in 2011?
Offer a very short reply. 0.31. What is the ratio of the Tax (as % of total tax revenue) in Afghanistan in 2009 to that in 2010?
Provide a succinct answer. 0.59. What is the ratio of the Tax (as % of total tax revenue) of Benin in 2009 to that in 2010?
Your answer should be compact. 1.53. What is the ratio of the Tax (as % of total tax revenue) in Dominican Republic in 2009 to that in 2010?
Give a very brief answer. 0.99. What is the ratio of the Tax (as % of total tax revenue) of Afghanistan in 2009 to that in 2011?
Ensure brevity in your answer.  0.1. What is the ratio of the Tax (as % of total tax revenue) of Benin in 2009 to that in 2011?
Your answer should be compact. 3.68. What is the ratio of the Tax (as % of total tax revenue) in Dominican Republic in 2009 to that in 2011?
Provide a short and direct response. 0.9. What is the ratio of the Tax (as % of total tax revenue) of Lao PDR in 2009 to that in 2011?
Ensure brevity in your answer.  0.61. What is the ratio of the Tax (as % of total tax revenue) in Afghanistan in 2010 to that in 2011?
Make the answer very short. 0.18. What is the ratio of the Tax (as % of total tax revenue) in Benin in 2010 to that in 2011?
Give a very brief answer. 2.4. What is the ratio of the Tax (as % of total tax revenue) of Dominican Republic in 2010 to that in 2011?
Offer a terse response. 0.91. What is the ratio of the Tax (as % of total tax revenue) in Lao PDR in 2010 to that in 2011?
Offer a terse response. 0.61. What is the difference between the highest and the second highest Tax (as % of total tax revenue) in Afghanistan?
Give a very brief answer. 0.07. What is the difference between the highest and the second highest Tax (as % of total tax revenue) in Benin?
Offer a very short reply. 0.05. What is the difference between the highest and the second highest Tax (as % of total tax revenue) in Dominican Republic?
Make the answer very short. 0.01. What is the difference between the highest and the second highest Tax (as % of total tax revenue) of Lao PDR?
Offer a terse response. 0.18. What is the difference between the highest and the lowest Tax (as % of total tax revenue) of Afghanistan?
Ensure brevity in your answer.  0.15. What is the difference between the highest and the lowest Tax (as % of total tax revenue) in Benin?
Your answer should be compact. 0.49. What is the difference between the highest and the lowest Tax (as % of total tax revenue) of Dominican Republic?
Provide a succinct answer. 0.03. What is the difference between the highest and the lowest Tax (as % of total tax revenue) in Lao PDR?
Provide a succinct answer. 1.06. 